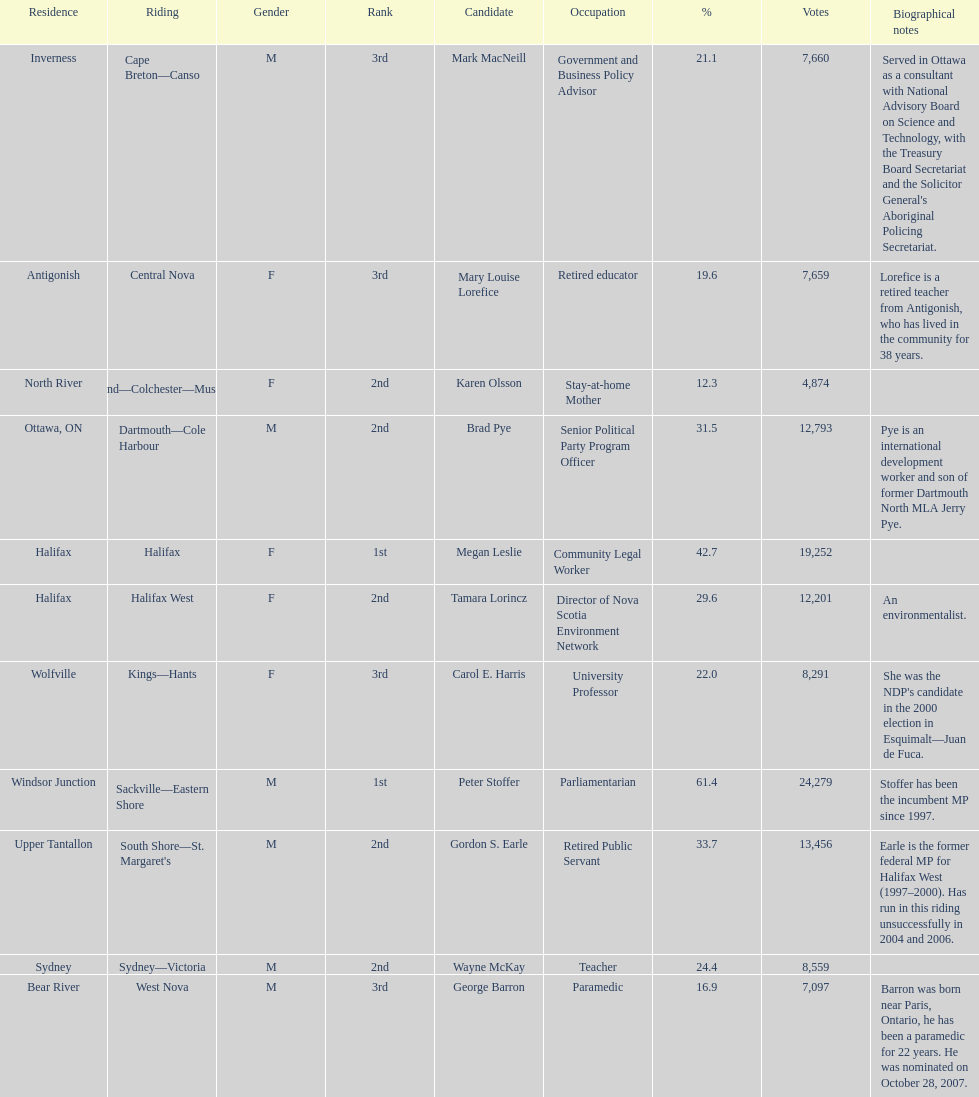How many candidates were from halifax? 2. 